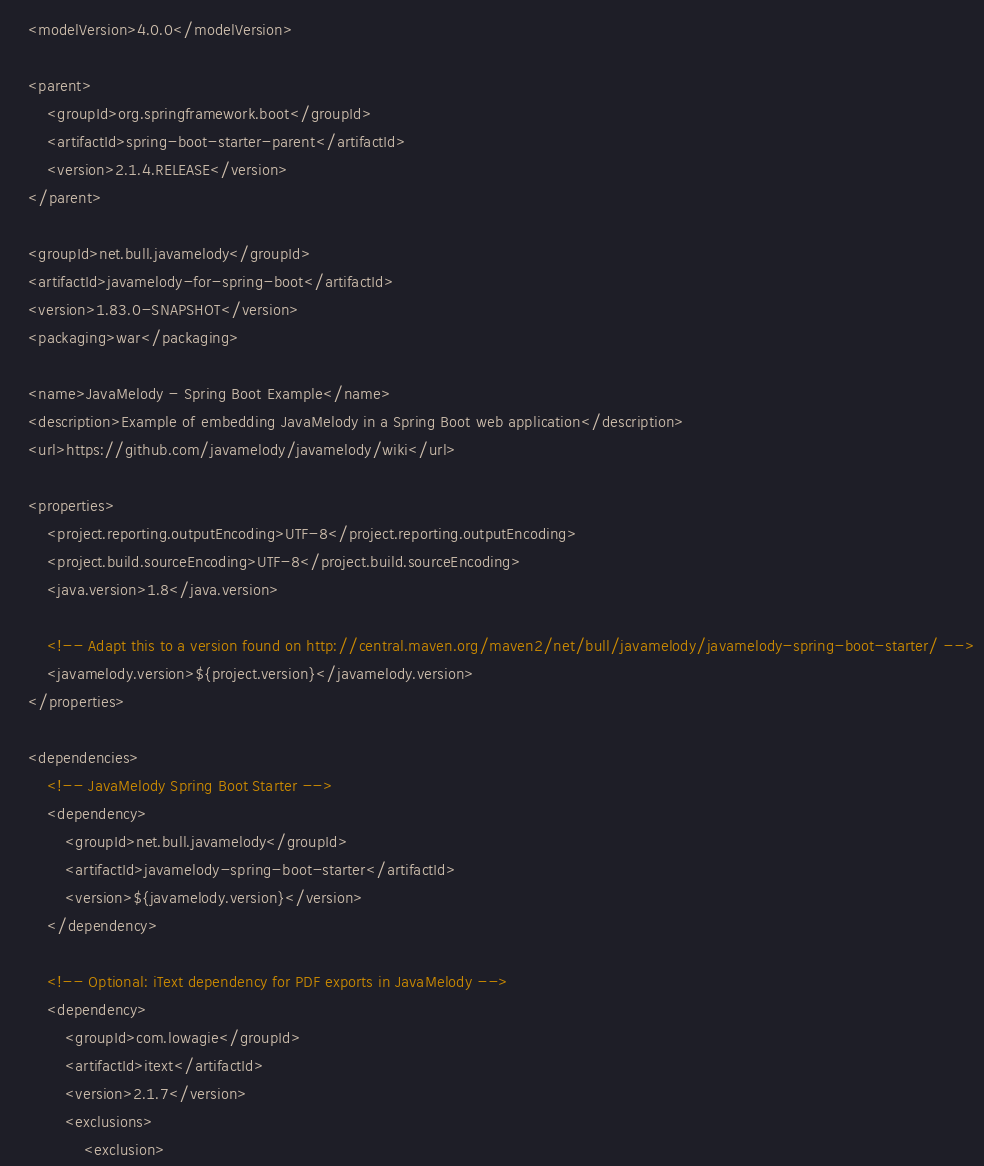Convert code to text. <code><loc_0><loc_0><loc_500><loc_500><_XML_>	<modelVersion>4.0.0</modelVersion>

	<parent>
		<groupId>org.springframework.boot</groupId>
		<artifactId>spring-boot-starter-parent</artifactId>
		<version>2.1.4.RELEASE</version>
	</parent>

	<groupId>net.bull.javamelody</groupId>
	<artifactId>javamelody-for-spring-boot</artifactId>
	<version>1.83.0-SNAPSHOT</version>
	<packaging>war</packaging>

	<name>JavaMelody - Spring Boot Example</name>
	<description>Example of embedding JavaMelody in a Spring Boot web application</description>
	<url>https://github.com/javamelody/javamelody/wiki</url>

	<properties>
		<project.reporting.outputEncoding>UTF-8</project.reporting.outputEncoding>
		<project.build.sourceEncoding>UTF-8</project.build.sourceEncoding>
		<java.version>1.8</java.version>

		<!-- Adapt this to a version found on http://central.maven.org/maven2/net/bull/javamelody/javamelody-spring-boot-starter/ -->
		<javamelody.version>${project.version}</javamelody.version>
	</properties>

	<dependencies>
		<!-- JavaMelody Spring Boot Starter -->
		<dependency>
			<groupId>net.bull.javamelody</groupId>
			<artifactId>javamelody-spring-boot-starter</artifactId>
			<version>${javamelody.version}</version>
		</dependency>

		<!-- Optional: iText dependency for PDF exports in JavaMelody -->
		<dependency>
			<groupId>com.lowagie</groupId>
			<artifactId>itext</artifactId>
			<version>2.1.7</version>
			<exclusions>
				<exclusion></code> 